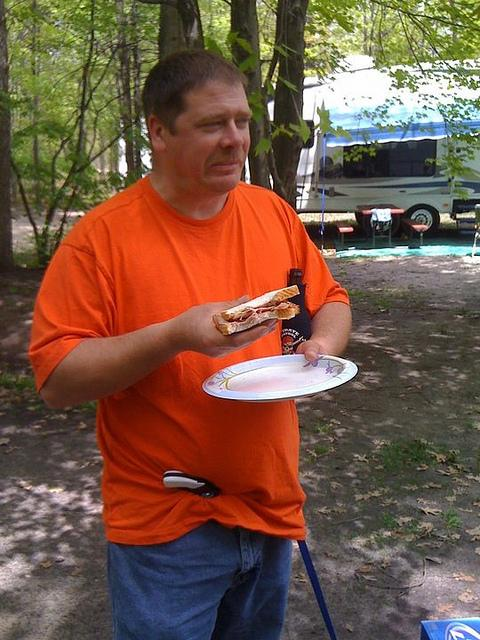How would this man defend himself if attacked? Please explain your reasoning. gun. The man has a firearm on his waist. if someone tries to harm him he'll use his firearm. 